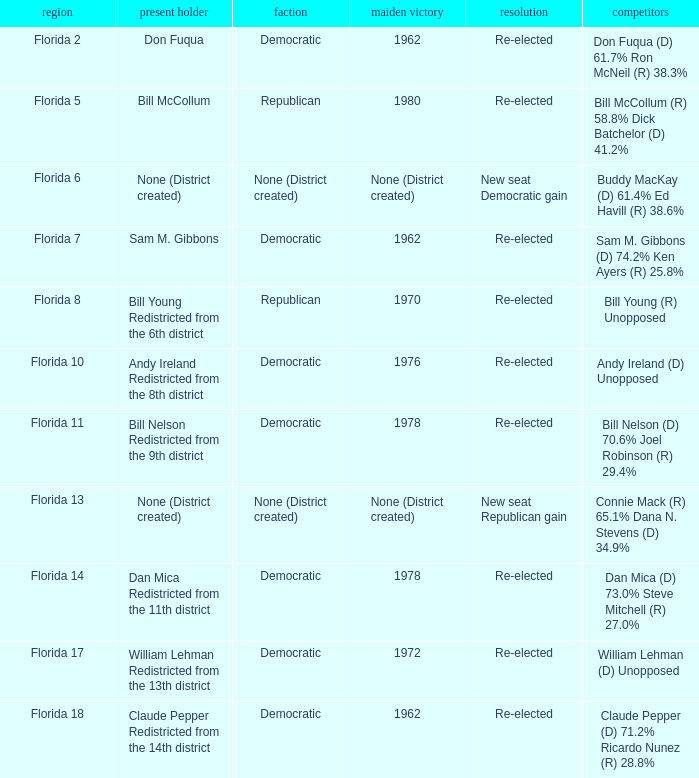What's the result with district being florida 7 Re-elected. 